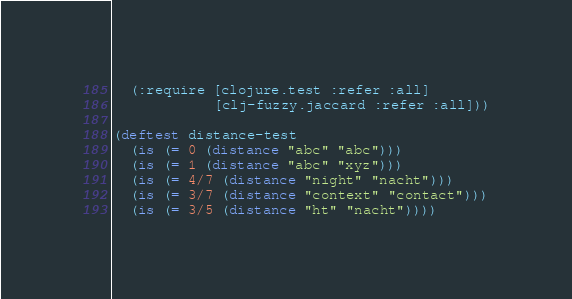Convert code to text. <code><loc_0><loc_0><loc_500><loc_500><_Clojure_>  (:require [clojure.test :refer :all]
            [clj-fuzzy.jaccard :refer :all]))

(deftest distance-test
  (is (= 0 (distance "abc" "abc")))
  (is (= 1 (distance "abc" "xyz")))
  (is (= 4/7 (distance "night" "nacht")))
  (is (= 3/7 (distance "context" "contact")))
  (is (= 3/5 (distance "ht" "nacht"))))
</code> 